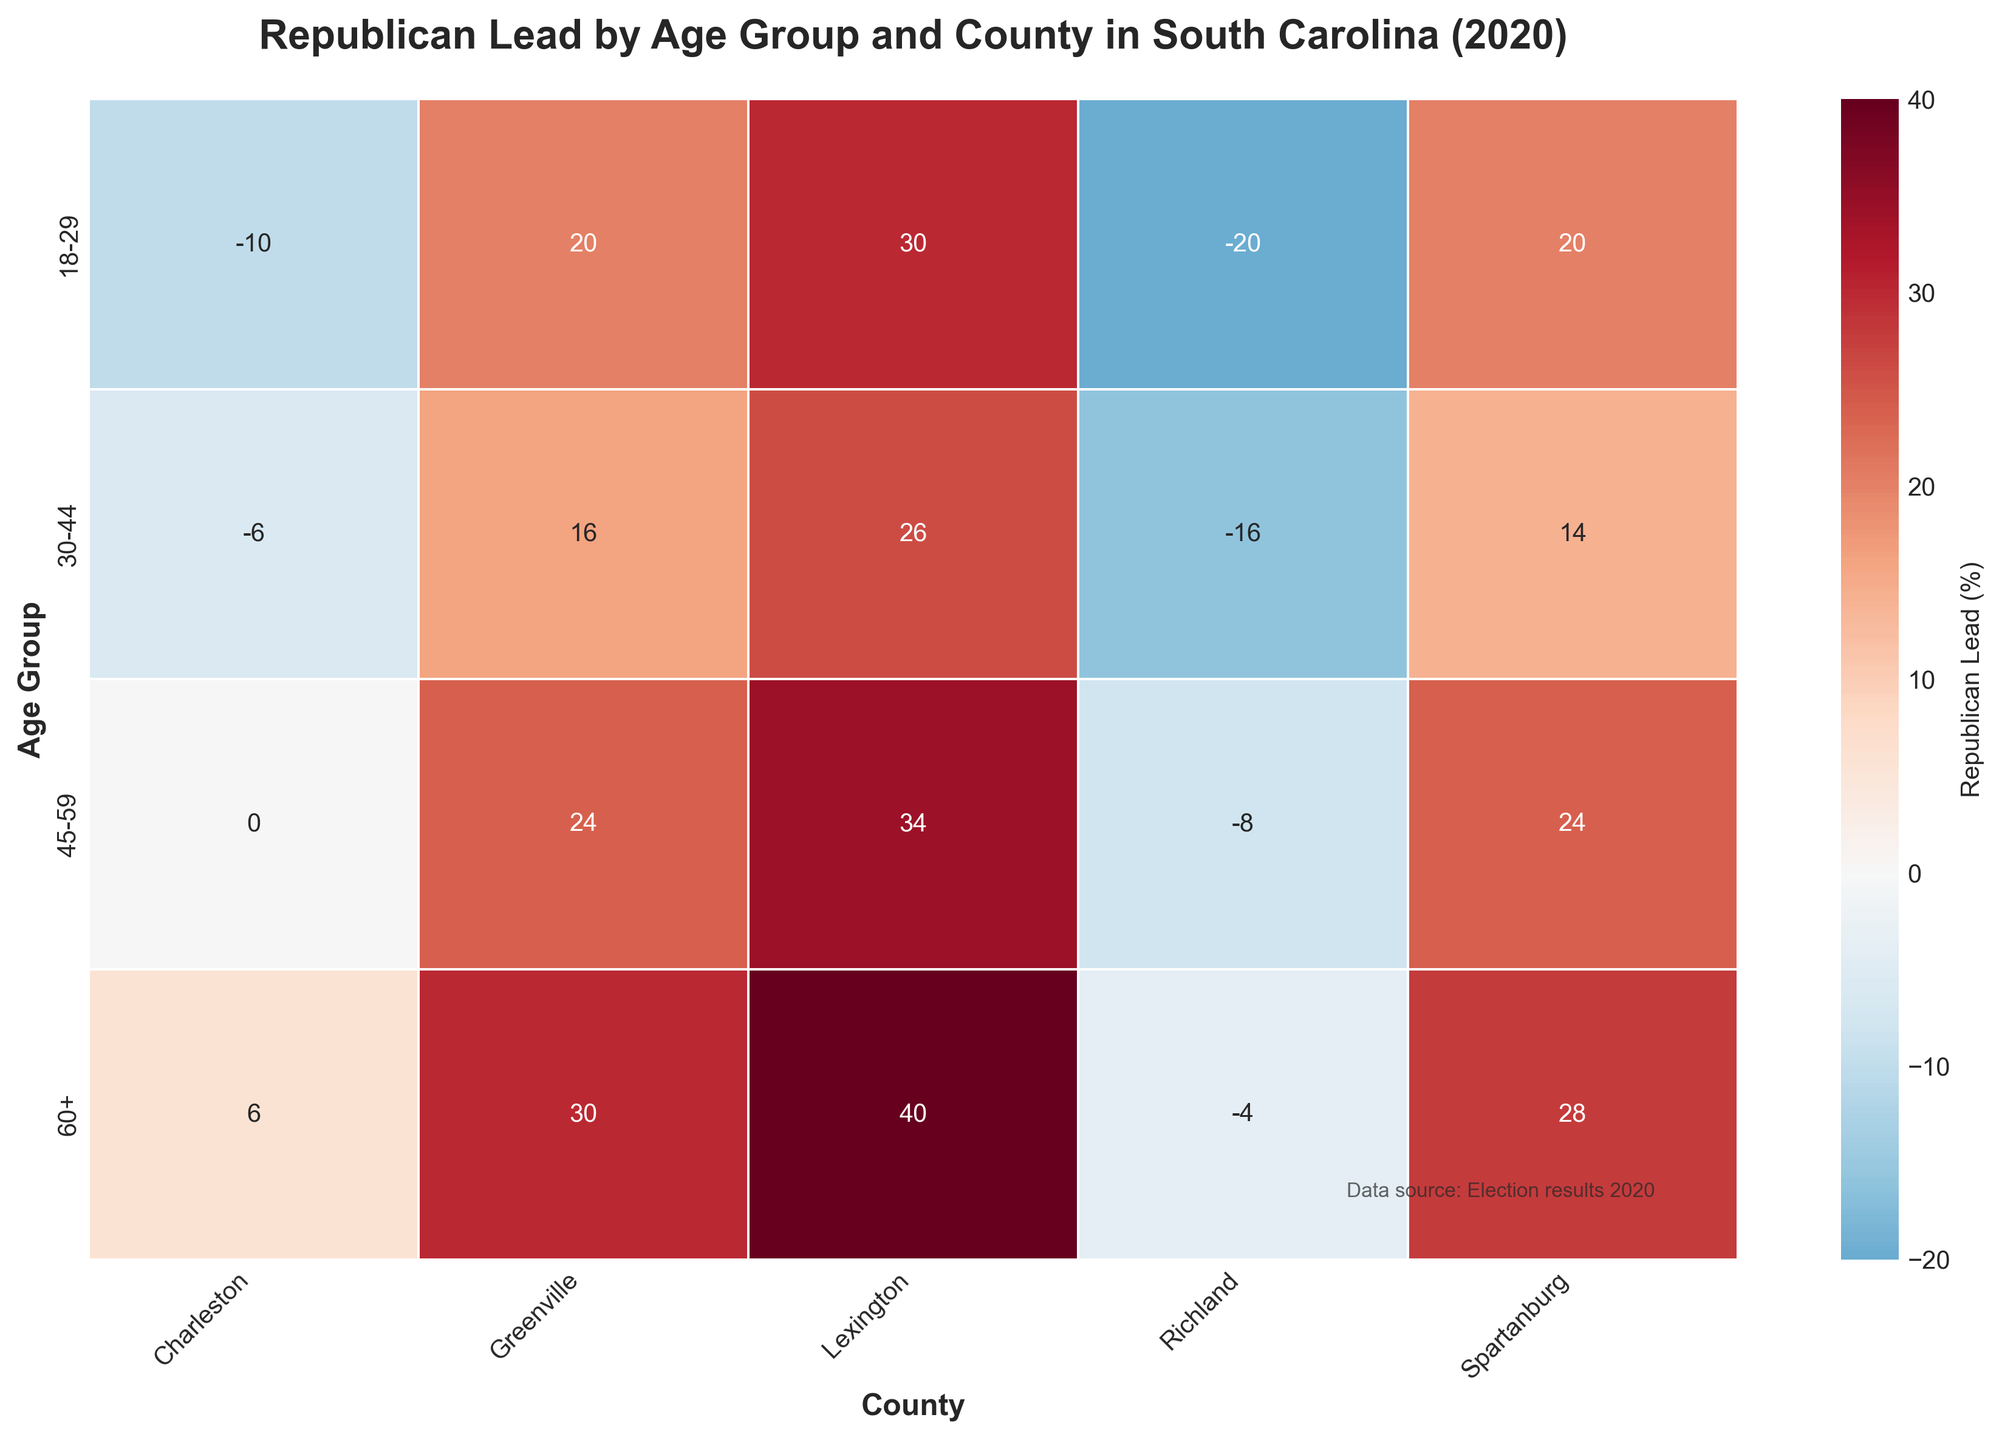What is the title of the heatmap? The title is usually displayed at the top of the figure. In this case, the heatmap title is "Republican Lead by Age Group and County in South Carolina (2020)."
Answer: Republican Lead by Age Group and County in South Carolina (2020) Which age group has the highest Republican lead in Charleston County? To determine this, look at the values associated with Charleston County in each age group. The highest number indicates the largest Republican lead. The 60+ age group in Charleston has the highest Republican lead with a value of 6.
Answer: 60+ How many counties are represented in the heatmap? The x-axis labels denote the counties. A quick count of these labels will give the number of counties. There are 5 counties mentioned: Charleston, Greenville, Richland, Lexington, and Spartanburg.
Answer: 5 What is the Republican lead for the 30-44 age group in Greenville County? Find the intersection of the 30-44 age group and Greenville County in the heatmap. The number at this intersection represents the Republican lead, which is 16.
Answer: 16 Which county shows the most significant Democratic gain in the 18-29 age group from 2016 to 2020? To identify this, find the smallest Republican lead (or highest negative number) among the 18-29 age group across all counties. The least positive or most negative value here will indicate the smallest Republican lead or a Democratic gain. In Charleston County, the figure is -10.
Answer: Charleston How does the Republican lead compare between the 18-29 and 60+ age groups in Lexington County? Check the values corresponding to Lexington County for both age groups. For 18-29, the lead is 30, and for 60+, the lead is 40. The Republican lead increases by 10 points from 18-29 to 60+.
Answer: Increases by 10 Which age group shows little to no preference shift in Charleston County between Democrats and Republicans? Look for the age group in Charleston where the lead value is closest to zero. For Charleston, the value for the 45-59 age group is 0, meaning little to no preference shift.
Answer: 45-59 What color represents a Republican lead in the heatmap? In the heatmap, color gradients typically indicate variances. Here, blue represents Democratic lead, red represents Republican lead. Republican lead values are represented with shades of red.
Answer: Red 